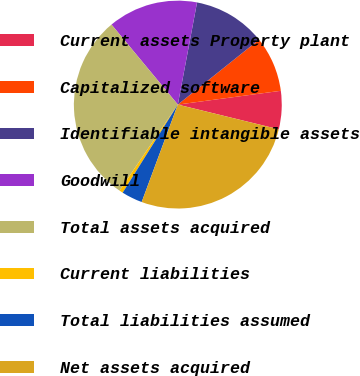Convert chart to OTSL. <chart><loc_0><loc_0><loc_500><loc_500><pie_chart><fcel>Current assets Property plant<fcel>Capitalized software<fcel>Identifiable intangible assets<fcel>Goodwill<fcel>Total assets acquired<fcel>Current liabilities<fcel>Total liabilities assumed<fcel>Net assets acquired<nl><fcel>5.94%<fcel>8.62%<fcel>11.3%<fcel>13.98%<fcel>29.51%<fcel>0.57%<fcel>3.25%<fcel>26.83%<nl></chart> 